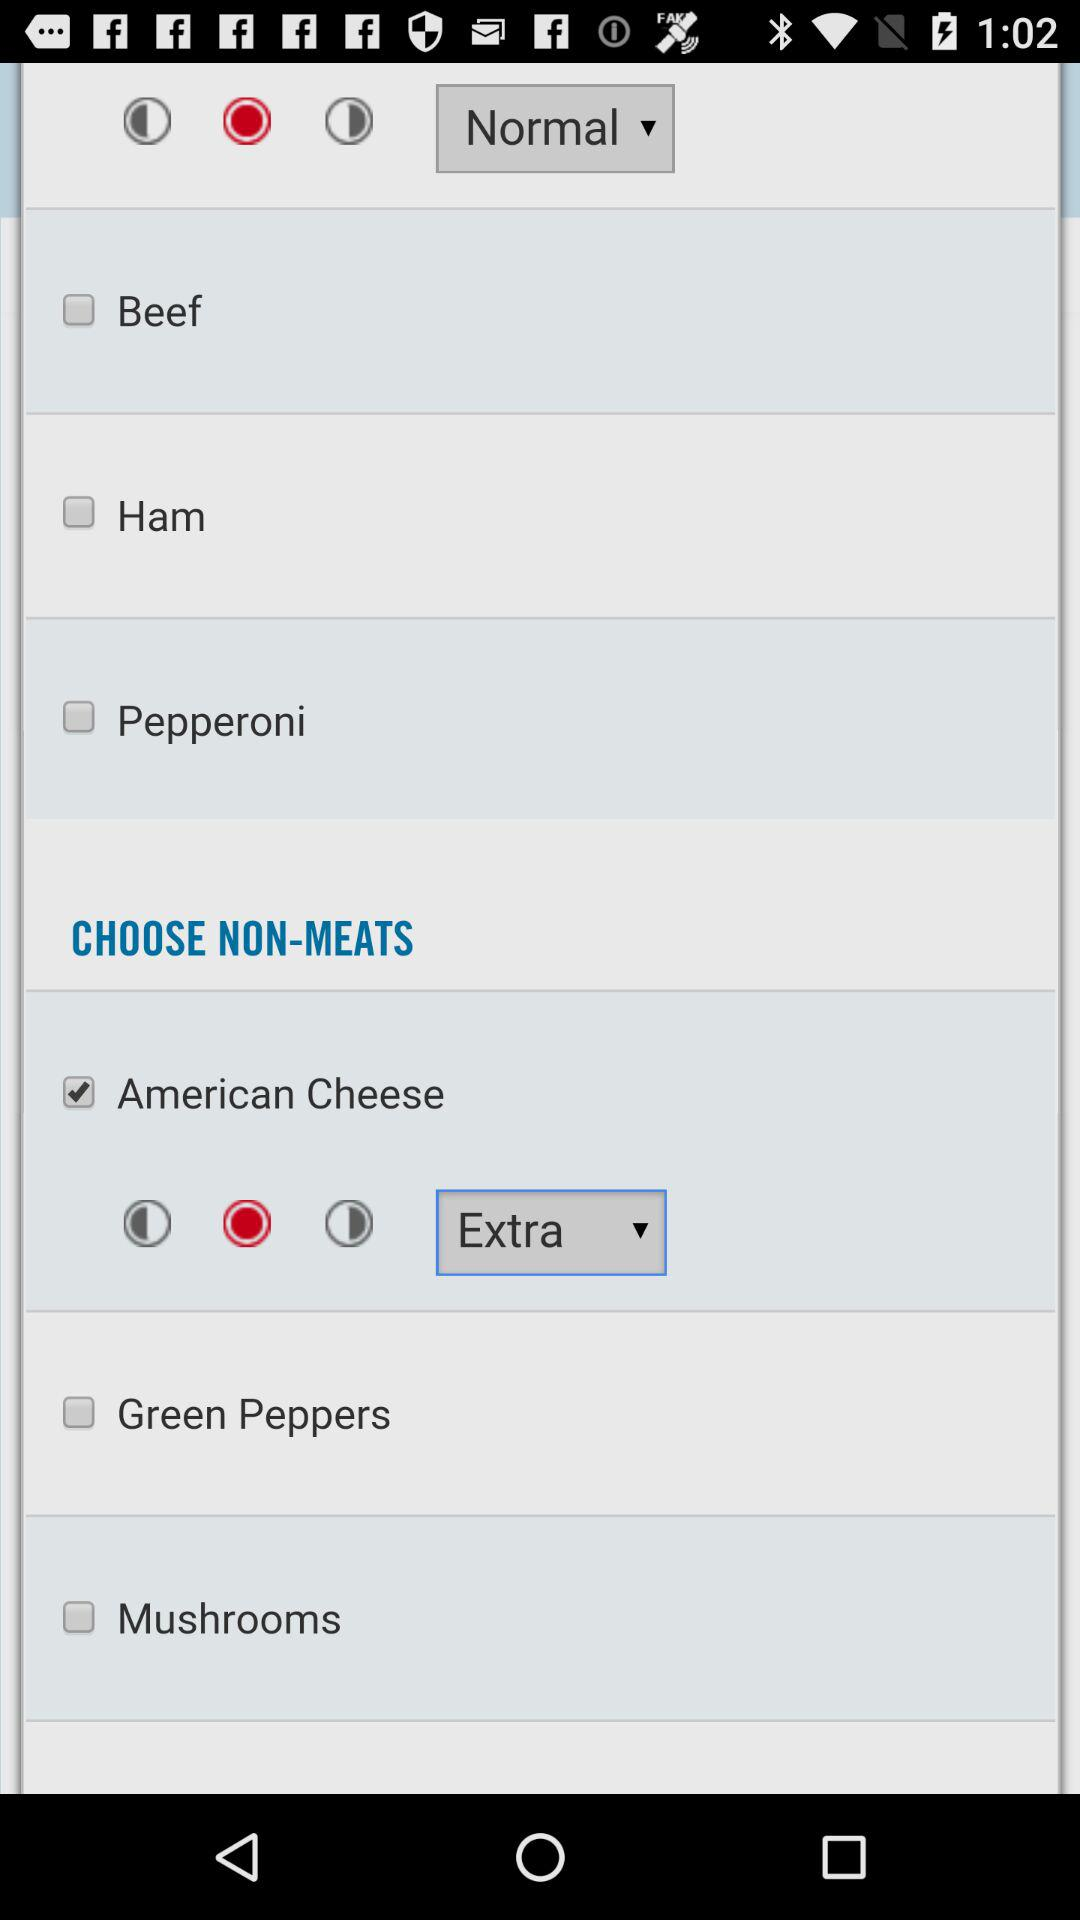Is "Green Peppers" selected or not? "Green Peppers" is not selected. 